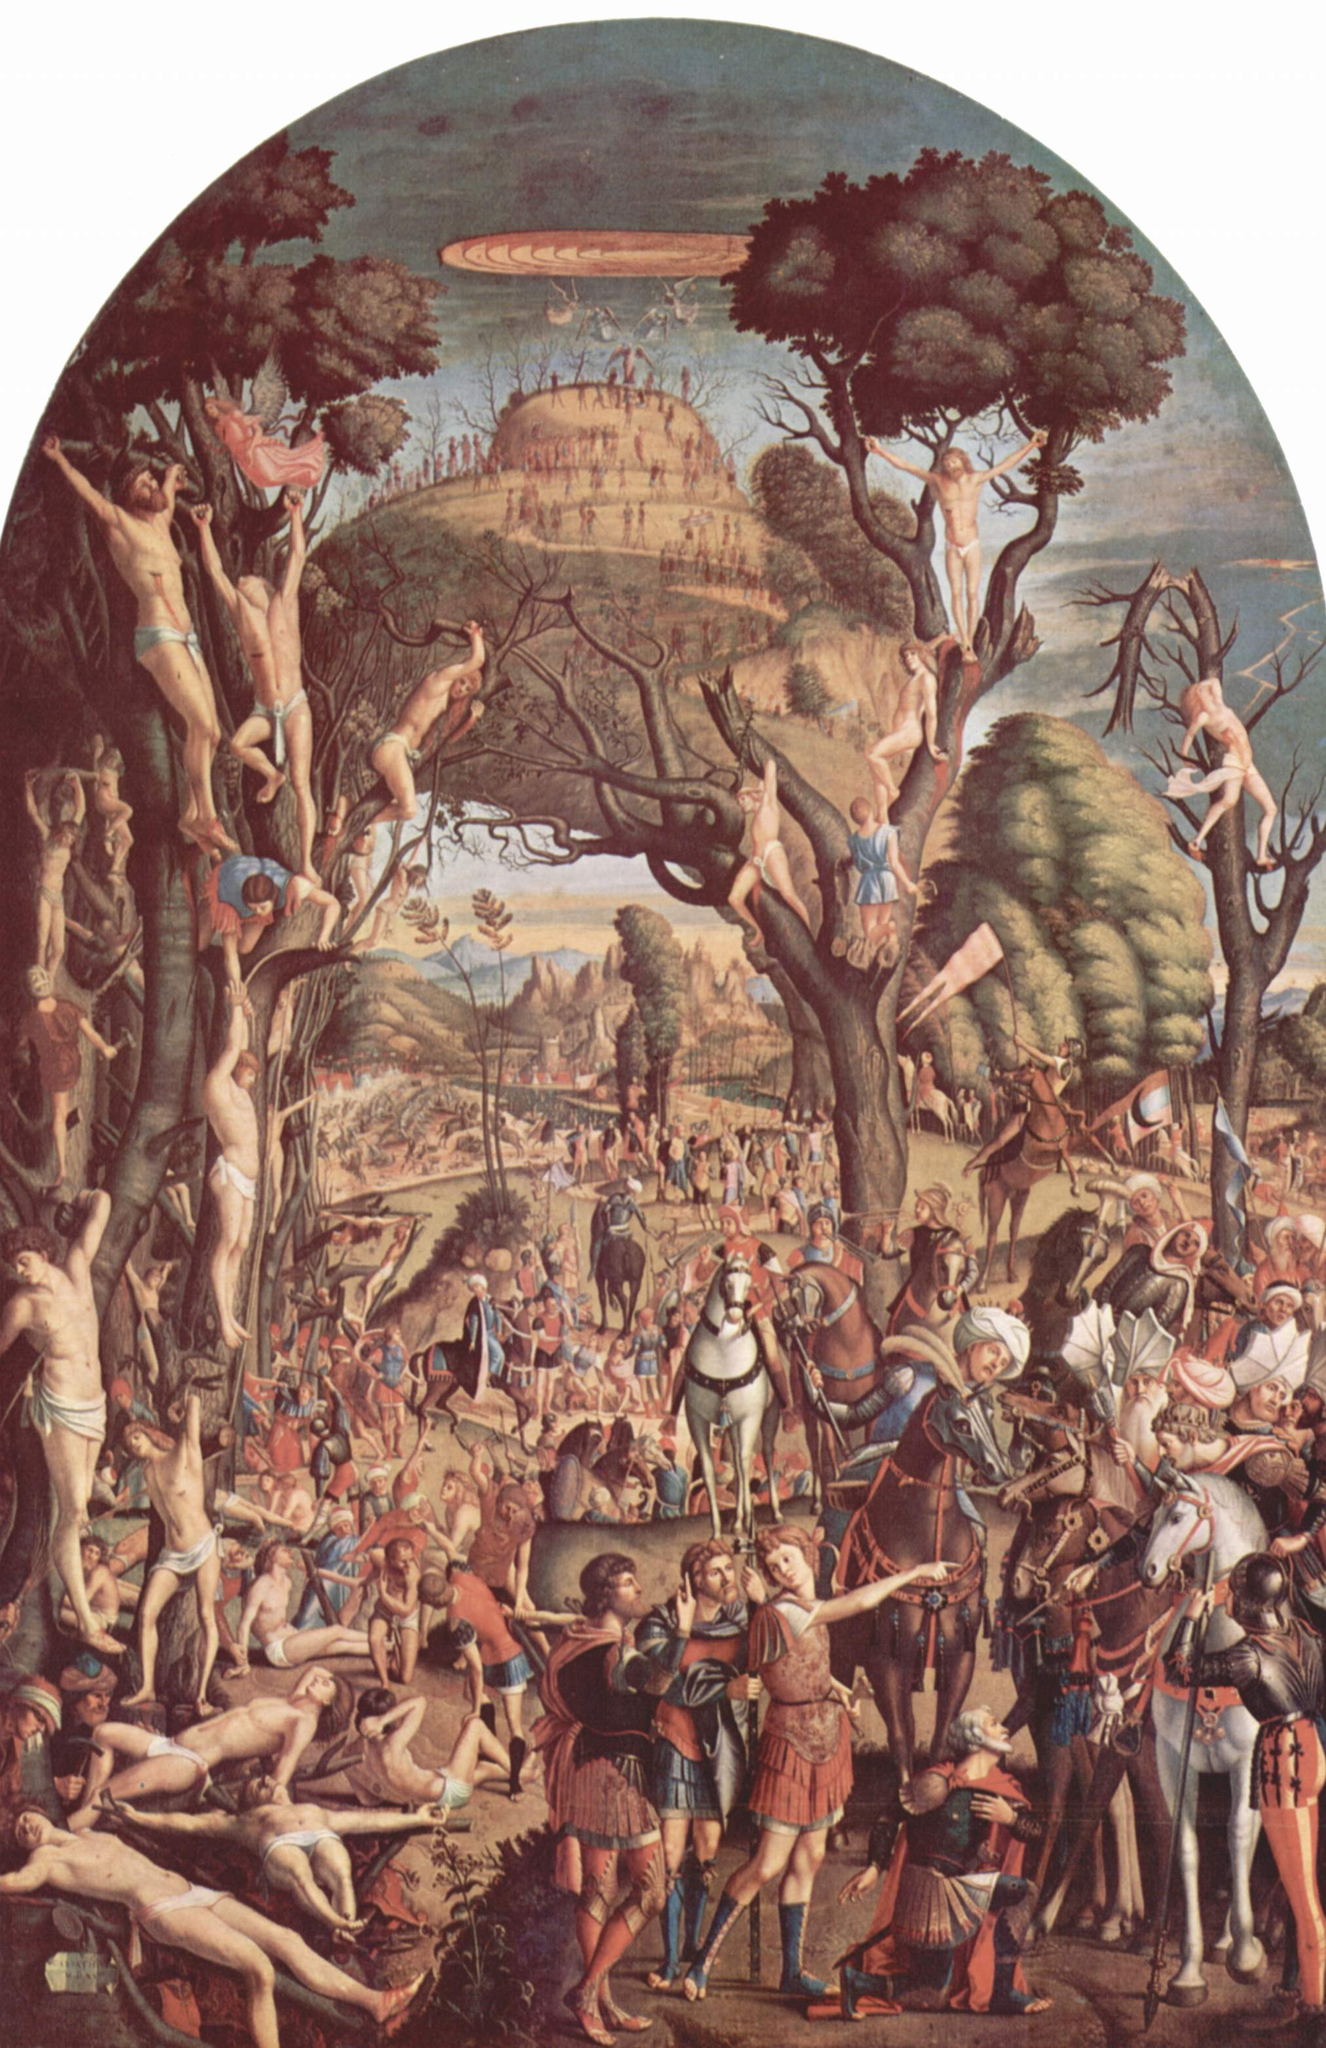What are the key elements in this picture? The image is a captivating representation of the Renaissance era, painted in the distinctive Mannerist style. The scene is a fantastical one, filled with nude figures playfully frolicking in a tree. Their elongated forms and exaggerated poses are characteristic of the Mannerist style, adding a sense of drama and movement to the composition.

In the foreground, a group of soldiers and a knight on horseback add a contrasting element of realism and gravity to the otherwise whimsical scene. Their clothing, brightly accented against the predominantly earth-toned palette of the painting, draws the viewer's attention and adds depth to the narrative.

The background of the painting opens up to a serene landscape, with a river meandering its way towards a city in the distance. This backdrop provides a sense of scale and context to the fantastical scene unfolding in the foreground.

Overall, the painting is a rich tapestry of elements that come together to create a visually engaging narrative, embodying the artistic ideals of the Renaissance era and the Mannerist style. 